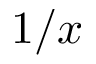Convert formula to latex. <formula><loc_0><loc_0><loc_500><loc_500>1 / x</formula> 